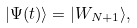Convert formula to latex. <formula><loc_0><loc_0><loc_500><loc_500>| \Psi ( t ) \rangle = | W _ { N + 1 } \rangle ,</formula> 